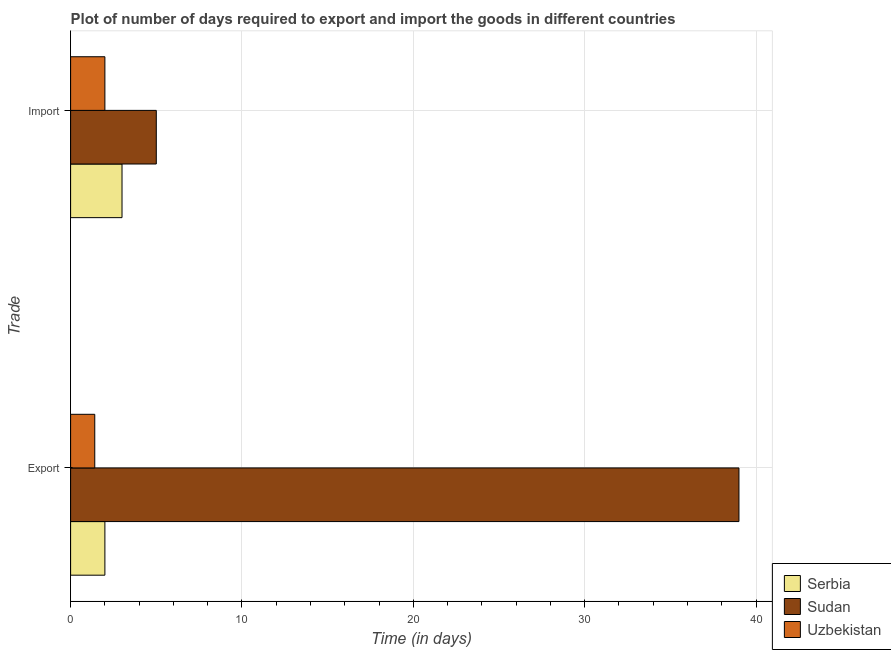Are the number of bars per tick equal to the number of legend labels?
Ensure brevity in your answer.  Yes. How many bars are there on the 1st tick from the top?
Provide a short and direct response. 3. What is the label of the 2nd group of bars from the top?
Provide a short and direct response. Export. What is the time required to import in Serbia?
Ensure brevity in your answer.  3. Across all countries, what is the maximum time required to import?
Give a very brief answer. 5. Across all countries, what is the minimum time required to import?
Make the answer very short. 2. In which country was the time required to import maximum?
Provide a succinct answer. Sudan. In which country was the time required to import minimum?
Keep it short and to the point. Uzbekistan. What is the total time required to export in the graph?
Give a very brief answer. 42.41. What is the difference between the time required to export in Sudan and that in Serbia?
Your answer should be very brief. 37. What is the difference between the time required to import in Uzbekistan and the time required to export in Sudan?
Provide a succinct answer. -37. What is the average time required to import per country?
Make the answer very short. 3.33. What is the difference between the time required to import and time required to export in Sudan?
Your answer should be compact. -34. What is the ratio of the time required to import in Sudan to that in Serbia?
Provide a short and direct response. 1.67. Is the time required to import in Uzbekistan less than that in Sudan?
Offer a very short reply. Yes. What does the 2nd bar from the top in Export represents?
Offer a terse response. Sudan. What does the 1st bar from the bottom in Import represents?
Keep it short and to the point. Serbia. Are all the bars in the graph horizontal?
Your response must be concise. Yes. How many countries are there in the graph?
Provide a succinct answer. 3. Does the graph contain any zero values?
Keep it short and to the point. No. How many legend labels are there?
Your response must be concise. 3. How are the legend labels stacked?
Provide a succinct answer. Vertical. What is the title of the graph?
Your response must be concise. Plot of number of days required to export and import the goods in different countries. Does "Guam" appear as one of the legend labels in the graph?
Give a very brief answer. No. What is the label or title of the X-axis?
Ensure brevity in your answer.  Time (in days). What is the label or title of the Y-axis?
Offer a terse response. Trade. What is the Time (in days) in Serbia in Export?
Your response must be concise. 2. What is the Time (in days) of Sudan in Export?
Offer a very short reply. 39. What is the Time (in days) in Uzbekistan in Export?
Give a very brief answer. 1.41. What is the Time (in days) in Serbia in Import?
Provide a succinct answer. 3. Across all Trade, what is the maximum Time (in days) of Serbia?
Offer a terse response. 3. Across all Trade, what is the maximum Time (in days) of Uzbekistan?
Your response must be concise. 2. Across all Trade, what is the minimum Time (in days) of Sudan?
Your answer should be very brief. 5. Across all Trade, what is the minimum Time (in days) in Uzbekistan?
Give a very brief answer. 1.41. What is the total Time (in days) of Serbia in the graph?
Provide a succinct answer. 5. What is the total Time (in days) in Uzbekistan in the graph?
Make the answer very short. 3.41. What is the difference between the Time (in days) in Uzbekistan in Export and that in Import?
Your answer should be compact. -0.59. What is the difference between the Time (in days) in Serbia in Export and the Time (in days) in Sudan in Import?
Your response must be concise. -3. What is the difference between the Time (in days) of Serbia in Export and the Time (in days) of Uzbekistan in Import?
Your answer should be very brief. 0. What is the average Time (in days) in Serbia per Trade?
Give a very brief answer. 2.5. What is the average Time (in days) in Uzbekistan per Trade?
Your answer should be compact. 1.71. What is the difference between the Time (in days) of Serbia and Time (in days) of Sudan in Export?
Provide a succinct answer. -37. What is the difference between the Time (in days) of Serbia and Time (in days) of Uzbekistan in Export?
Offer a very short reply. 0.59. What is the difference between the Time (in days) in Sudan and Time (in days) in Uzbekistan in Export?
Provide a short and direct response. 37.59. What is the difference between the Time (in days) of Sudan and Time (in days) of Uzbekistan in Import?
Your answer should be very brief. 3. What is the ratio of the Time (in days) of Uzbekistan in Export to that in Import?
Offer a very short reply. 0.7. What is the difference between the highest and the second highest Time (in days) of Uzbekistan?
Give a very brief answer. 0.59. What is the difference between the highest and the lowest Time (in days) in Serbia?
Offer a very short reply. 1. What is the difference between the highest and the lowest Time (in days) of Uzbekistan?
Keep it short and to the point. 0.59. 